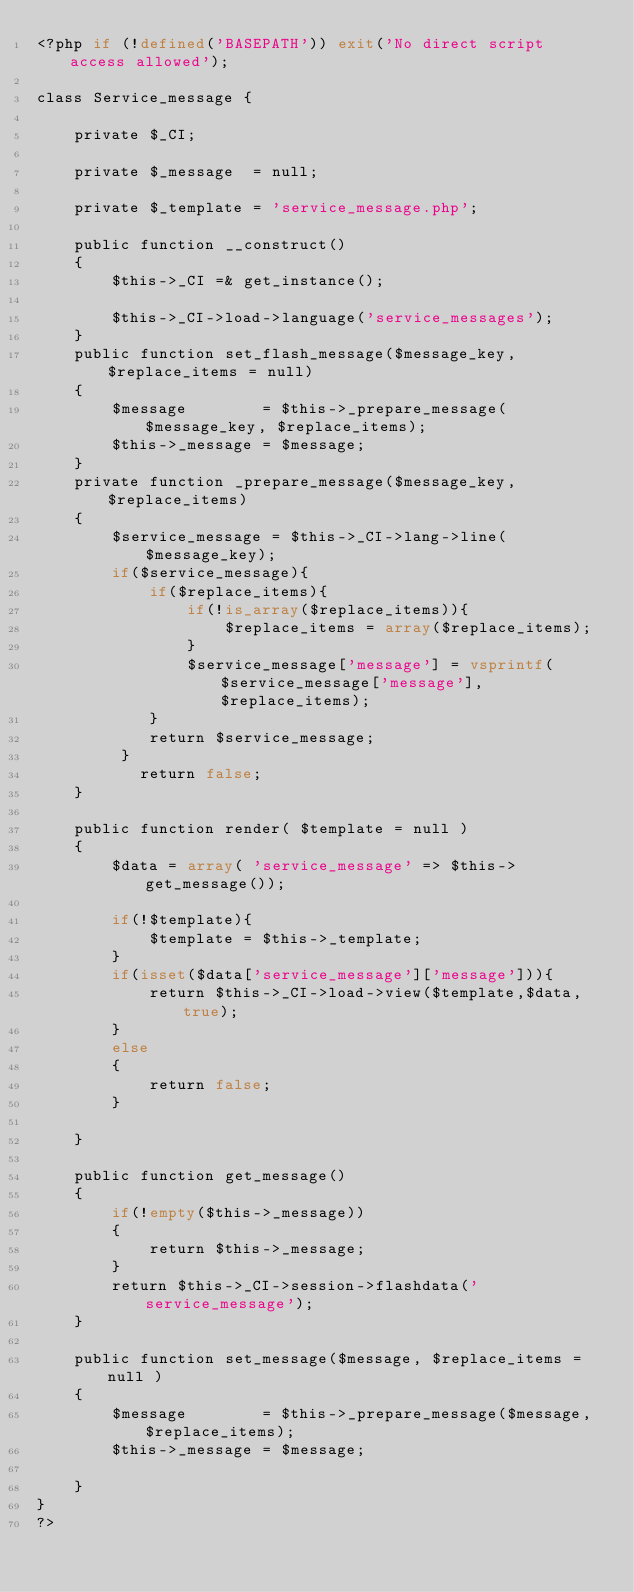<code> <loc_0><loc_0><loc_500><loc_500><_PHP_><?php if (!defined('BASEPATH')) exit('No direct script access allowed');

class Service_message {
    
    private $_CI;
    
    private $_message  = null;
    
    private $_template = 'service_message.php';
    
    public function __construct()
    {
        $this->_CI =& get_instance();
        
        $this->_CI->load->language('service_messages');
    }
    public function set_flash_message($message_key, $replace_items = null)
    {
        $message        = $this->_prepare_message($message_key, $replace_items);
        $this->_message = $message;
    }
    private function _prepare_message($message_key, $replace_items)
    {
        $service_message = $this->_CI->lang->line($message_key);
        if($service_message){
            if($replace_items){
                if(!is_array($replace_items)){
                    $replace_items = array($replace_items);
                }
                $service_message['message'] = vsprintf($service_message['message'], $replace_items);
            }
            return $service_message;
         }
           return false;
    }
    
    public function render( $template = null )
    {
        $data = array( 'service_message' => $this->get_message());
        
        if(!$template){
            $template = $this->_template;
        }
        if(isset($data['service_message']['message'])){
            return $this->_CI->load->view($template,$data,true);
        }
        else
        {
            return false;
        }
        
    }
    
    public function get_message()
    {
        if(!empty($this->_message))
        {
            return $this->_message;
        }
        return $this->_CI->session->flashdata('service_message');
    }
    
    public function set_message($message, $replace_items = null )
    {
        $message        = $this->_prepare_message($message, $replace_items);
        $this->_message = $message;
        
    }
}
?></code> 